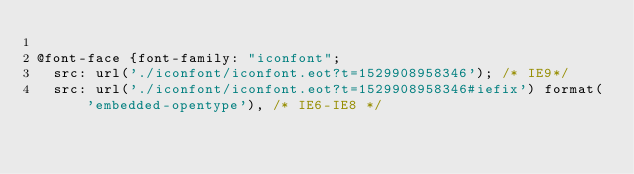Convert code to text. <code><loc_0><loc_0><loc_500><loc_500><_CSS_>
@font-face {font-family: "iconfont";
  src: url('./iconfont/iconfont.eot?t=1529908958346'); /* IE9*/
  src: url('./iconfont/iconfont.eot?t=1529908958346#iefix') format('embedded-opentype'), /* IE6-IE8 */</code> 